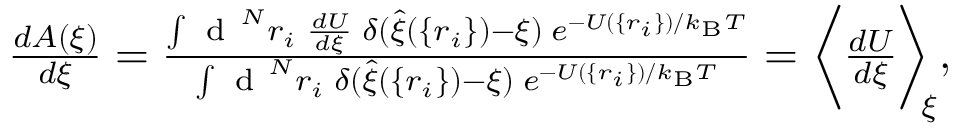Convert formula to latex. <formula><loc_0><loc_0><loc_500><loc_500>\begin{array} { r } { \frac { d A ( \xi ) } { d \xi } = \frac { \int d ^ { N } r _ { i } \, \frac { d U } { d \xi } \, \delta ( \hat { \xi } ( \{ r _ { i } \} ) - \xi ) \, e ^ { - U ( \{ r _ { i } \} ) / k _ { B } T } } { \int d ^ { N } r _ { i } \, \delta ( \hat { \xi } ( \{ r _ { i } \} ) - \xi ) \, e ^ { - U ( \{ r _ { i } \} ) / k _ { B } T } } = \left \langle \frac { d U } { d \xi } \right \rangle _ { \, \xi } , } \end{array}</formula> 